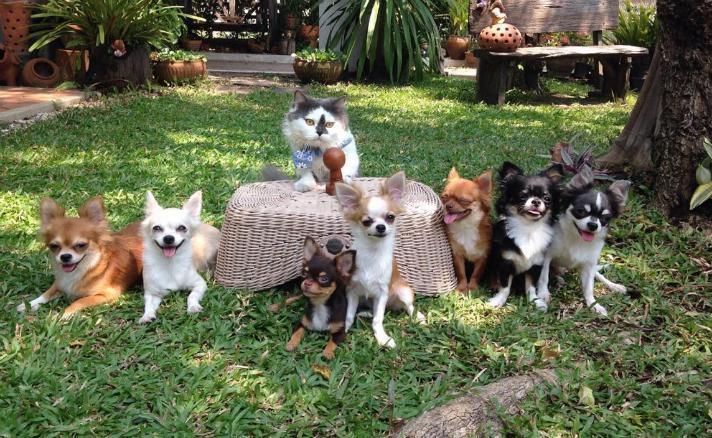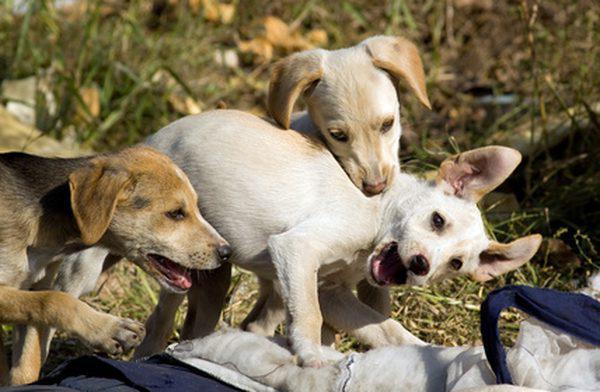The first image is the image on the left, the second image is the image on the right. Evaluate the accuracy of this statement regarding the images: "there is a row of animals dressed in clothes". Is it true? Answer yes or no. No. 